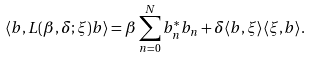<formula> <loc_0><loc_0><loc_500><loc_500>\langle b , L ( \beta , \delta ; \xi ) b \rangle = \beta \sum _ { n = 0 } ^ { N } b _ { n } ^ { * } b _ { n } + \delta \langle b , \xi \rangle \langle \xi , b \rangle .</formula> 